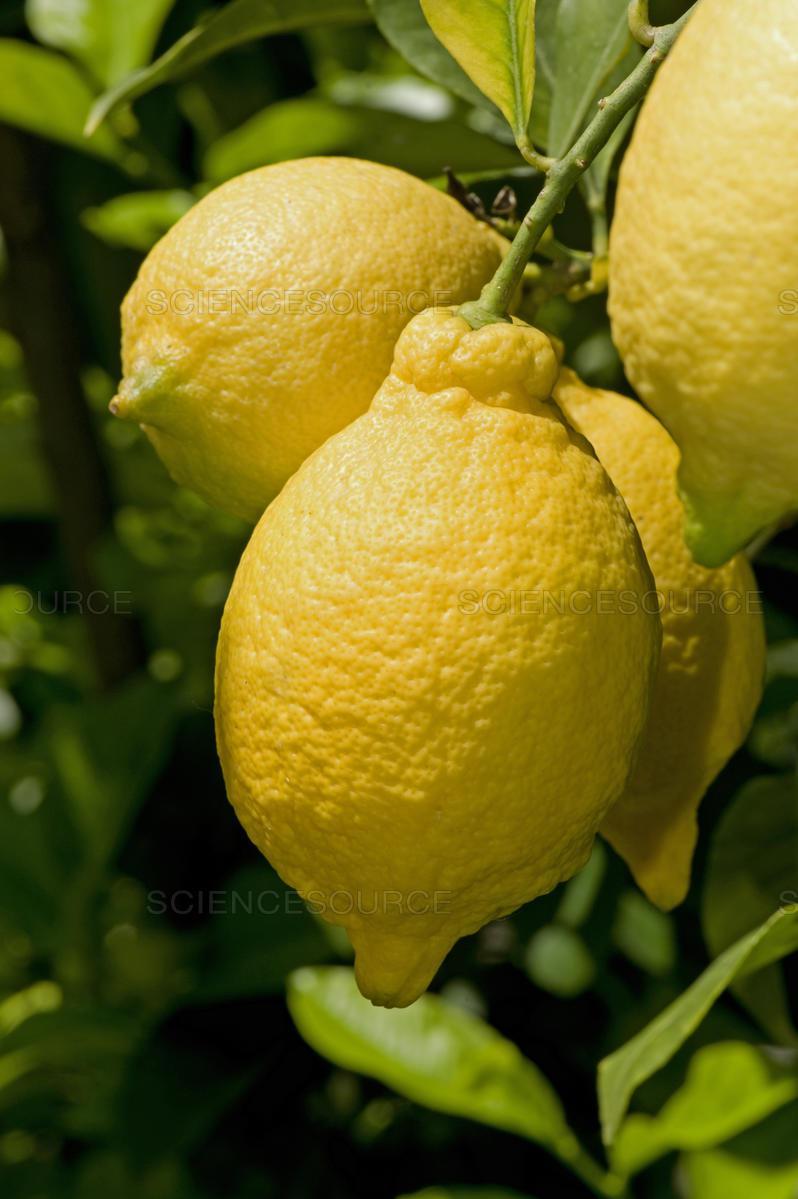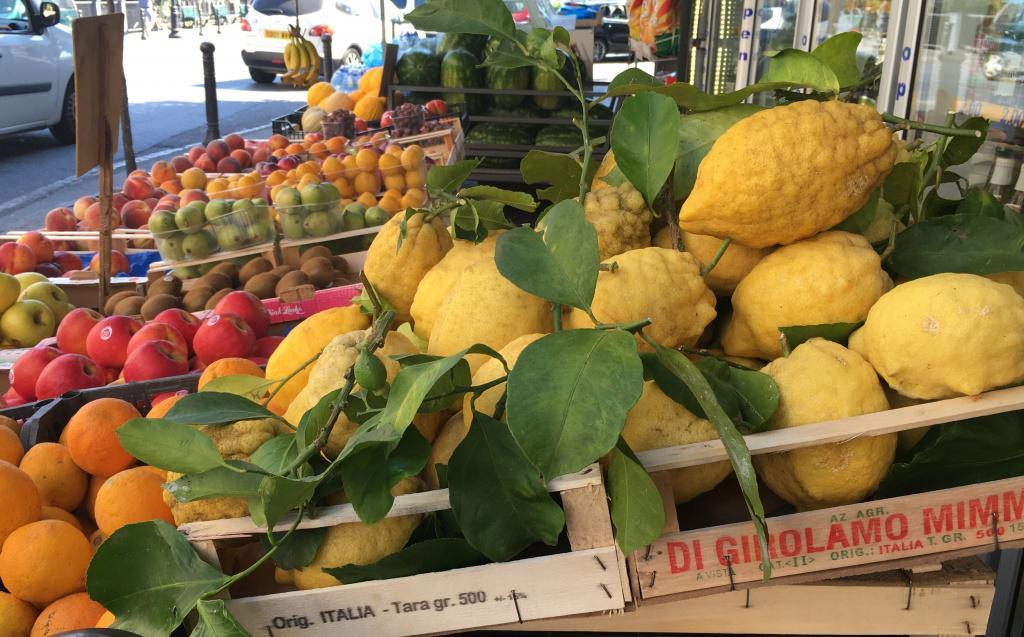The first image is the image on the left, the second image is the image on the right. Evaluate the accuracy of this statement regarding the images: "In at least one image there are no more then four lemons with leaves under them". Is it true? Answer yes or no. Yes. 